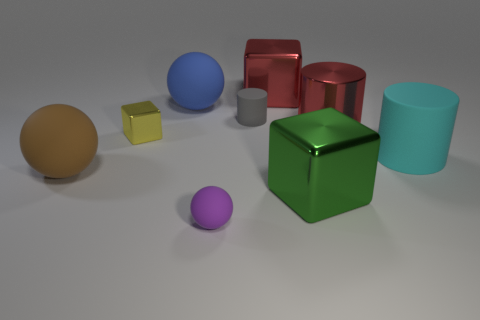Are the big sphere behind the large brown rubber thing and the small object in front of the cyan cylinder made of the same material?
Your answer should be very brief. Yes. There is a big rubber sphere behind the large brown thing; how many big cylinders are behind it?
Keep it short and to the point. 0. There is a small matte object in front of the green cube; does it have the same shape as the big matte object to the left of the large blue rubber ball?
Keep it short and to the point. Yes. How big is the object that is both in front of the large brown sphere and behind the tiny purple rubber thing?
Make the answer very short. Large. What is the color of the other large thing that is the same shape as the large blue object?
Provide a succinct answer. Brown. What color is the cube that is left of the rubber ball that is behind the big red metal cylinder?
Ensure brevity in your answer.  Yellow. There is a cyan rubber object; what shape is it?
Your answer should be compact. Cylinder. The object that is both behind the brown ball and on the left side of the large blue sphere has what shape?
Keep it short and to the point. Cube. What is the color of the small ball that is the same material as the large cyan cylinder?
Provide a short and direct response. Purple. There is a small thing that is in front of the large cylinder that is in front of the red shiny thing that is in front of the red block; what is its shape?
Give a very brief answer. Sphere. 